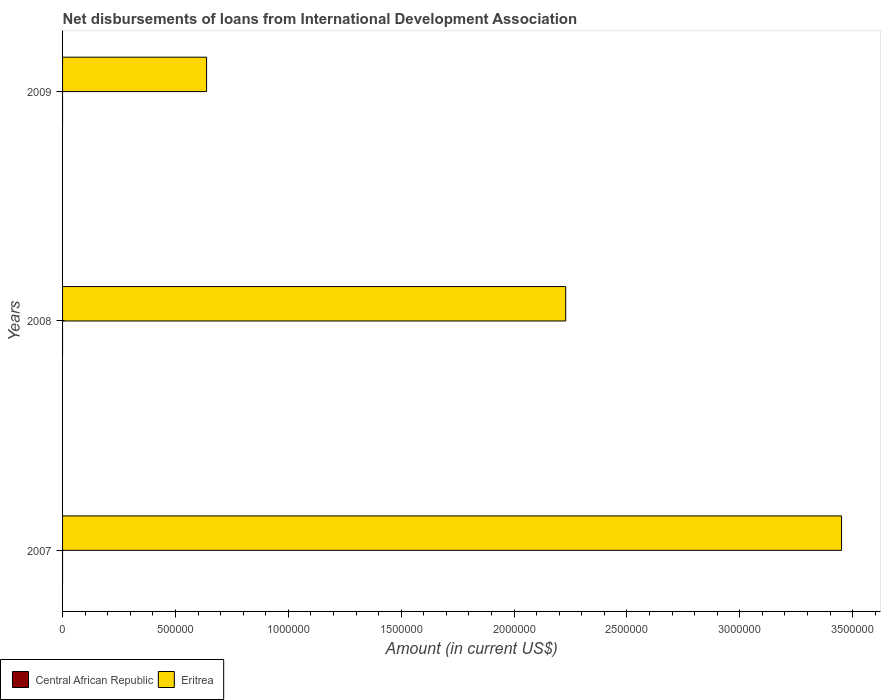Are the number of bars per tick equal to the number of legend labels?
Ensure brevity in your answer.  No. Are the number of bars on each tick of the Y-axis equal?
Your answer should be compact. Yes. How many bars are there on the 3rd tick from the top?
Ensure brevity in your answer.  1. In how many cases, is the number of bars for a given year not equal to the number of legend labels?
Your response must be concise. 3. What is the amount of loans disbursed in Eritrea in 2008?
Provide a short and direct response. 2.23e+06. Across all years, what is the maximum amount of loans disbursed in Eritrea?
Give a very brief answer. 3.45e+06. Across all years, what is the minimum amount of loans disbursed in Eritrea?
Make the answer very short. 6.38e+05. In which year was the amount of loans disbursed in Eritrea maximum?
Give a very brief answer. 2007. What is the total amount of loans disbursed in Central African Republic in the graph?
Give a very brief answer. 0. What is the difference between the amount of loans disbursed in Eritrea in 2007 and that in 2009?
Make the answer very short. 2.81e+06. What is the difference between the amount of loans disbursed in Eritrea in 2009 and the amount of loans disbursed in Central African Republic in 2008?
Make the answer very short. 6.38e+05. What is the average amount of loans disbursed in Eritrea per year?
Your response must be concise. 2.11e+06. In how many years, is the amount of loans disbursed in Central African Republic greater than 1700000 US$?
Your answer should be very brief. 0. What is the ratio of the amount of loans disbursed in Eritrea in 2007 to that in 2008?
Provide a succinct answer. 1.55. Is the amount of loans disbursed in Eritrea in 2008 less than that in 2009?
Offer a very short reply. No. What is the difference between the highest and the second highest amount of loans disbursed in Eritrea?
Your answer should be very brief. 1.22e+06. What is the difference between the highest and the lowest amount of loans disbursed in Eritrea?
Give a very brief answer. 2.81e+06. Are all the bars in the graph horizontal?
Provide a succinct answer. Yes. How many years are there in the graph?
Your answer should be compact. 3. Where does the legend appear in the graph?
Offer a very short reply. Bottom left. How are the legend labels stacked?
Give a very brief answer. Horizontal. What is the title of the graph?
Make the answer very short. Net disbursements of loans from International Development Association. Does "Gambia, The" appear as one of the legend labels in the graph?
Ensure brevity in your answer.  No. What is the label or title of the X-axis?
Provide a succinct answer. Amount (in current US$). What is the label or title of the Y-axis?
Your answer should be very brief. Years. What is the Amount (in current US$) of Central African Republic in 2007?
Your answer should be compact. 0. What is the Amount (in current US$) of Eritrea in 2007?
Provide a short and direct response. 3.45e+06. What is the Amount (in current US$) in Eritrea in 2008?
Your answer should be compact. 2.23e+06. What is the Amount (in current US$) in Eritrea in 2009?
Ensure brevity in your answer.  6.38e+05. Across all years, what is the maximum Amount (in current US$) in Eritrea?
Ensure brevity in your answer.  3.45e+06. Across all years, what is the minimum Amount (in current US$) of Eritrea?
Your answer should be compact. 6.38e+05. What is the total Amount (in current US$) of Eritrea in the graph?
Make the answer very short. 6.32e+06. What is the difference between the Amount (in current US$) in Eritrea in 2007 and that in 2008?
Keep it short and to the point. 1.22e+06. What is the difference between the Amount (in current US$) of Eritrea in 2007 and that in 2009?
Provide a short and direct response. 2.81e+06. What is the difference between the Amount (in current US$) in Eritrea in 2008 and that in 2009?
Provide a succinct answer. 1.59e+06. What is the average Amount (in current US$) in Eritrea per year?
Provide a short and direct response. 2.11e+06. What is the ratio of the Amount (in current US$) of Eritrea in 2007 to that in 2008?
Ensure brevity in your answer.  1.55. What is the ratio of the Amount (in current US$) of Eritrea in 2007 to that in 2009?
Your answer should be very brief. 5.41. What is the ratio of the Amount (in current US$) in Eritrea in 2008 to that in 2009?
Provide a succinct answer. 3.49. What is the difference between the highest and the second highest Amount (in current US$) of Eritrea?
Provide a short and direct response. 1.22e+06. What is the difference between the highest and the lowest Amount (in current US$) of Eritrea?
Your answer should be compact. 2.81e+06. 